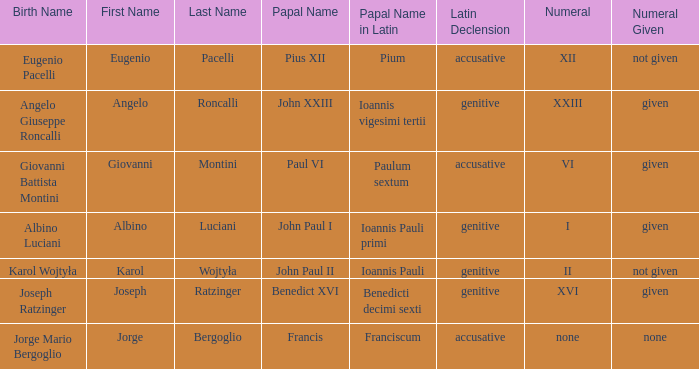For the pope born Eugenio Pacelli, what is the declension of his papal name? Accusative. 